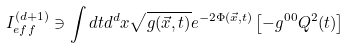Convert formula to latex. <formula><loc_0><loc_0><loc_500><loc_500>I _ { e f f } ^ { ( d + 1 ) } \ni \int d t d ^ { d } x \sqrt { g ( \vec { x } , t ) } e ^ { - 2 \Phi ( { \vec { x } } , t ) } \left [ - g ^ { 0 0 } Q ^ { 2 } ( t ) \right ]</formula> 